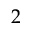Convert formula to latex. <formula><loc_0><loc_0><loc_500><loc_500>2</formula> 